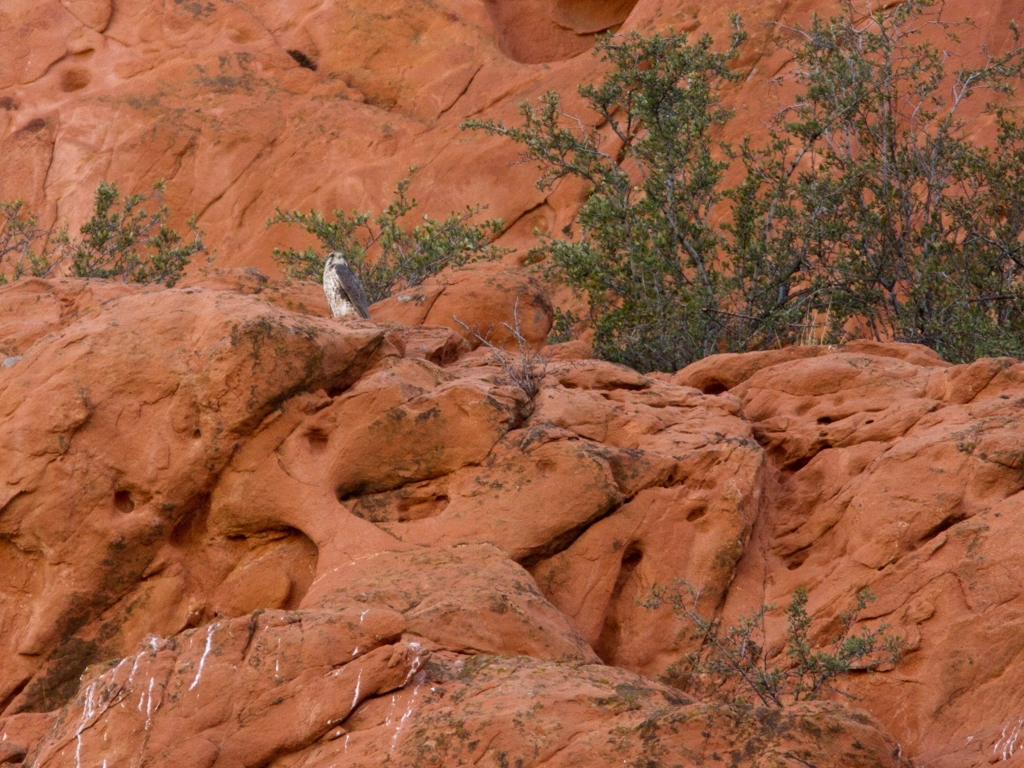Is there any distortion in the image? The image appears to be clear with no notable distortion affecting the visibility or integrity of the scene. It captures a natural environment, likely a rocky landscape, providing a crisp depiction of the textures and colors present in the setting. 